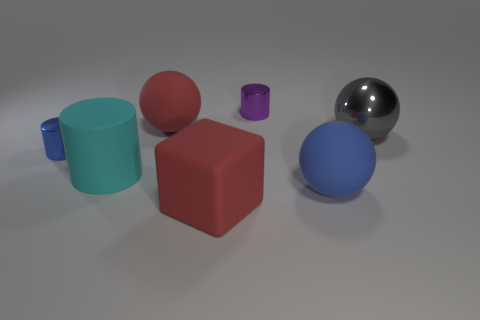Subtract all cyan balls. Subtract all gray cylinders. How many balls are left? 3 Add 2 big gray metal balls. How many objects exist? 9 Subtract all blocks. How many objects are left? 6 Subtract all tiny red rubber cylinders. Subtract all large red rubber things. How many objects are left? 5 Add 2 red matte spheres. How many red matte spheres are left? 3 Add 1 big shiny objects. How many big shiny objects exist? 2 Subtract 0 green spheres. How many objects are left? 7 